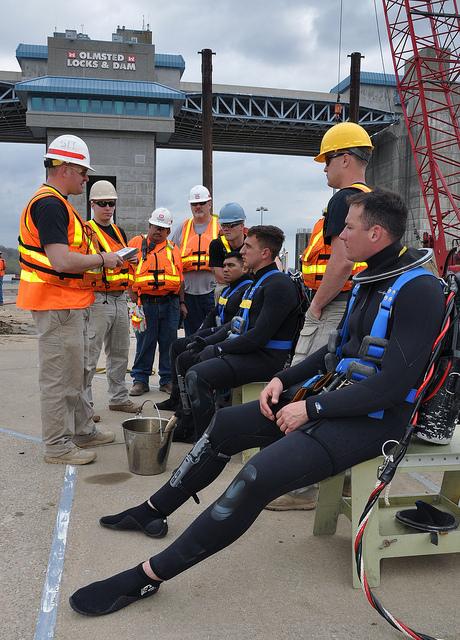What purpose do the yellow stripes on the vest serve?
Give a very brief answer. Safety. Why do some men have wetsuits?
Be succinct. Divers. What are the men in black preparing to do?
Quick response, please. Scuba dive. 